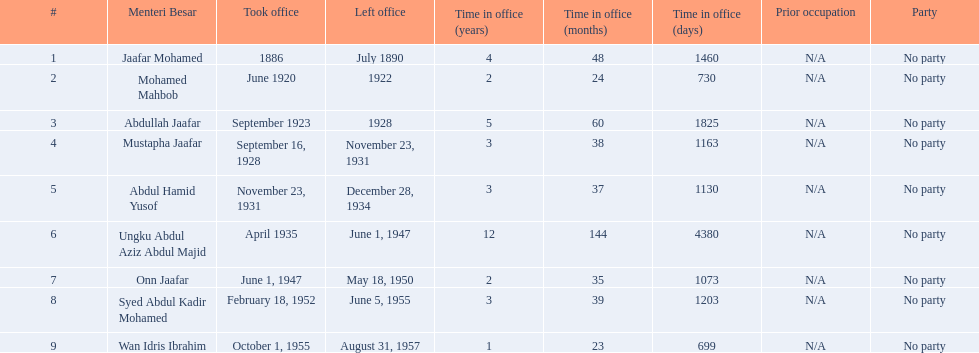Who were all of the menteri besars? Jaafar Mohamed, Mohamed Mahbob, Abdullah Jaafar, Mustapha Jaafar, Abdul Hamid Yusof, Ungku Abdul Aziz Abdul Majid, Onn Jaafar, Syed Abdul Kadir Mohamed, Wan Idris Ibrahim. When did they take office? 1886, June 1920, September 1923, September 16, 1928, November 23, 1931, April 1935, June 1, 1947, February 18, 1952, October 1, 1955. And when did they leave? July 1890, 1922, 1928, November 23, 1931, December 28, 1934, June 1, 1947, May 18, 1950, June 5, 1955, August 31, 1957. Now, who was in office for less than four years? Mohamed Mahbob. 